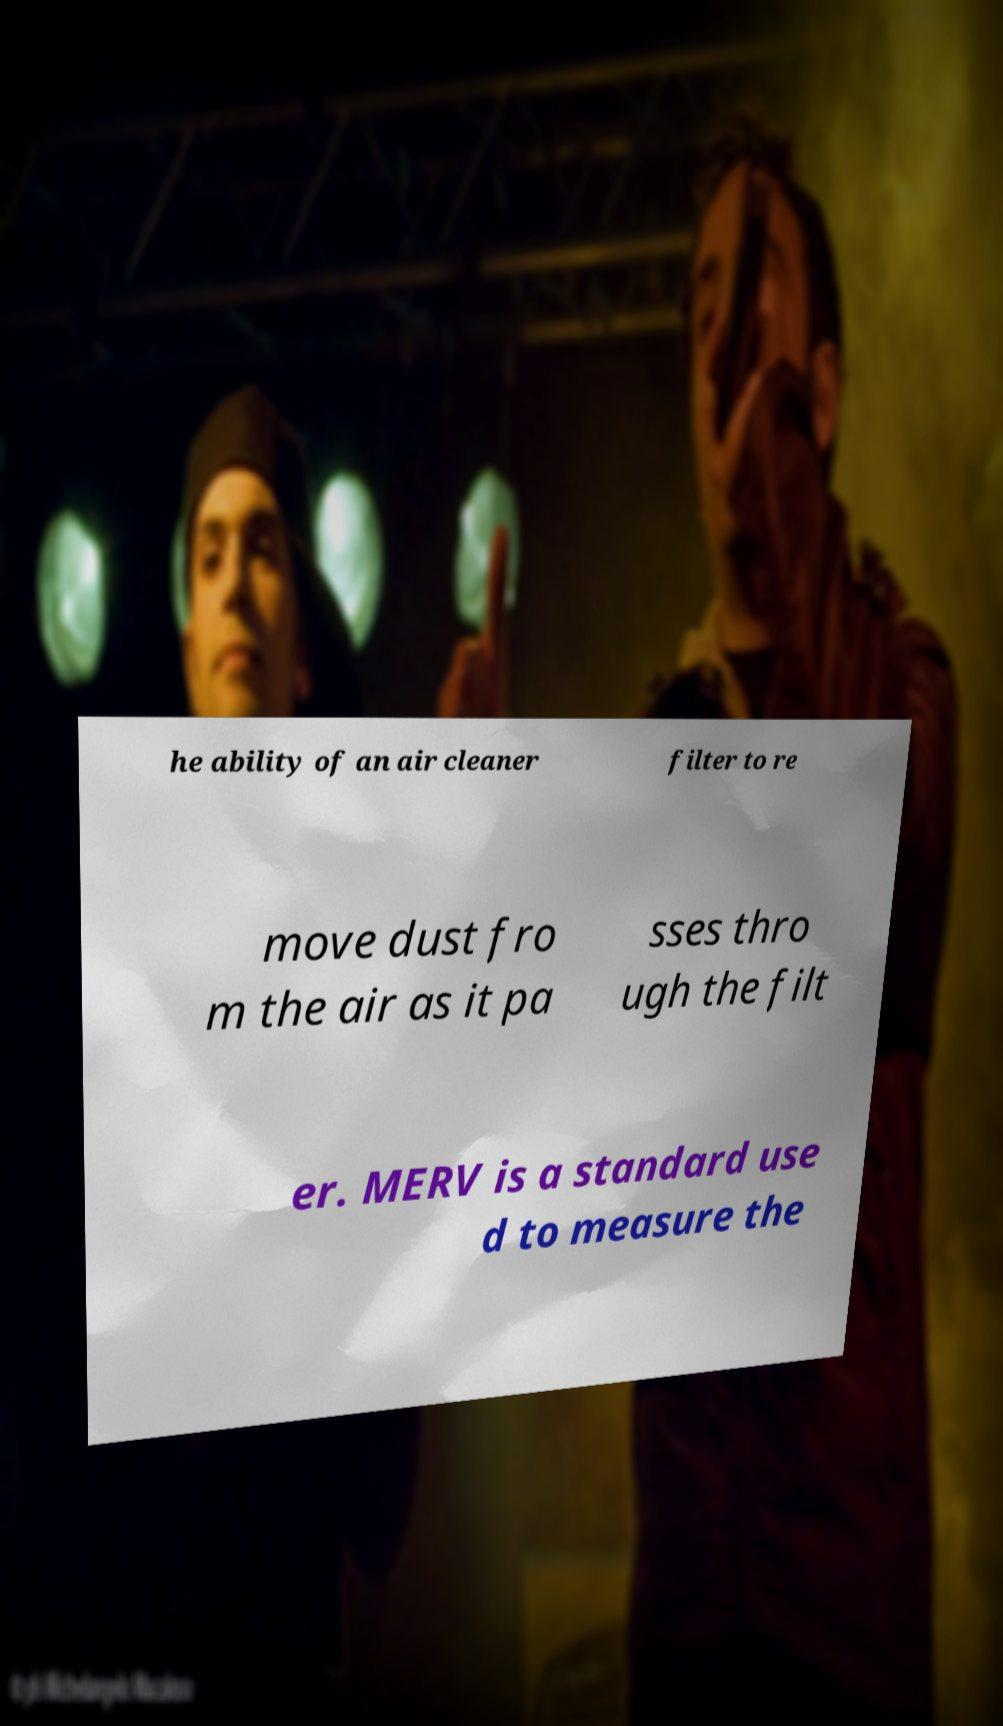Please read and relay the text visible in this image. What does it say? he ability of an air cleaner filter to re move dust fro m the air as it pa sses thro ugh the filt er. MERV is a standard use d to measure the 